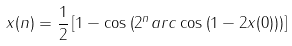Convert formula to latex. <formula><loc_0><loc_0><loc_500><loc_500>x ( n ) = \frac { 1 } { 2 } \left [ 1 - \cos \left ( 2 ^ { n } a r c \cos \left ( 1 - 2 x ( 0 ) \right ) \right ) \right ]</formula> 